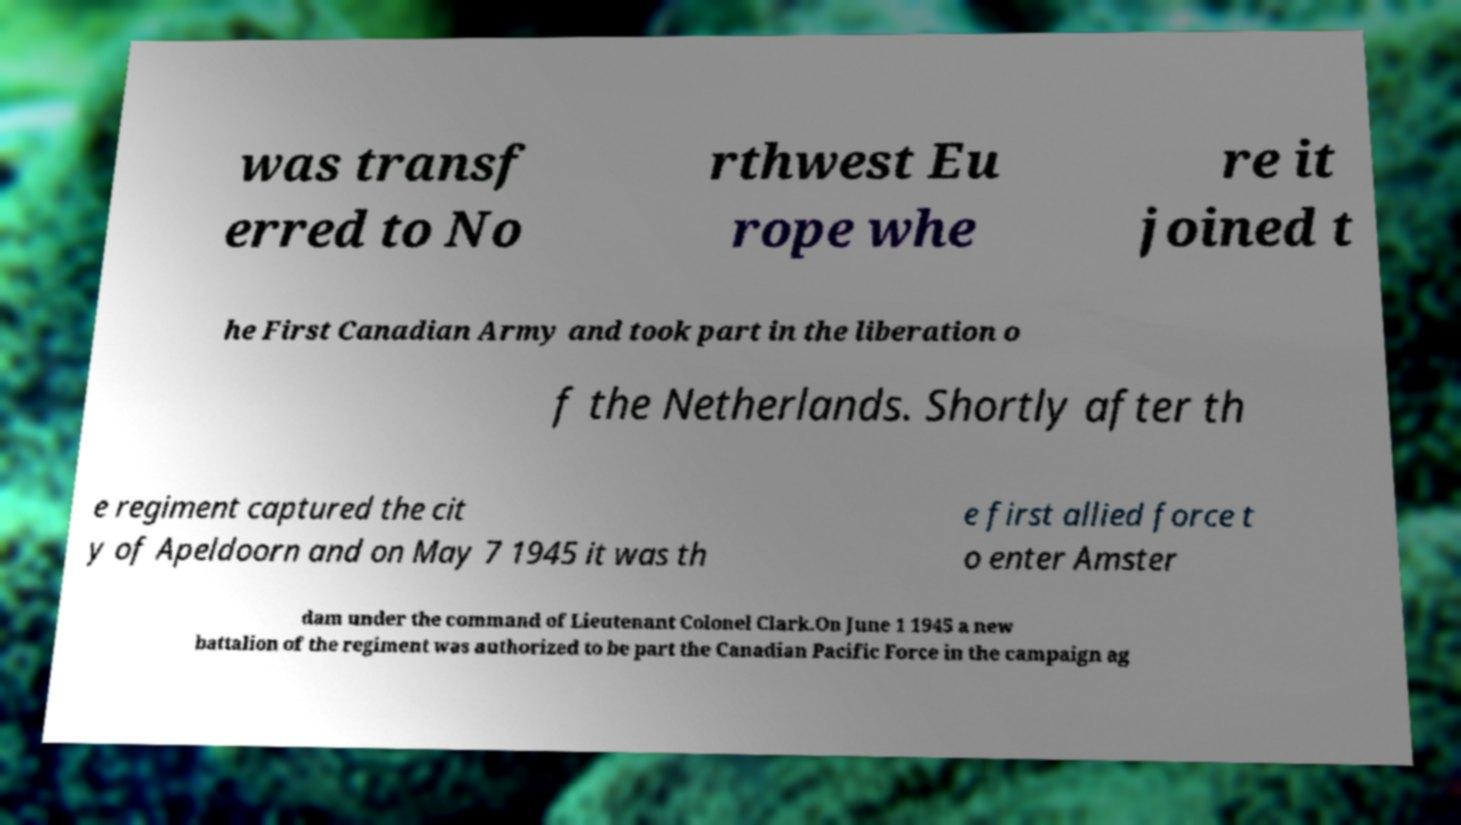Could you assist in decoding the text presented in this image and type it out clearly? was transf erred to No rthwest Eu rope whe re it joined t he First Canadian Army and took part in the liberation o f the Netherlands. Shortly after th e regiment captured the cit y of Apeldoorn and on May 7 1945 it was th e first allied force t o enter Amster dam under the command of Lieutenant Colonel Clark.On June 1 1945 a new battalion of the regiment was authorized to be part the Canadian Pacific Force in the campaign ag 